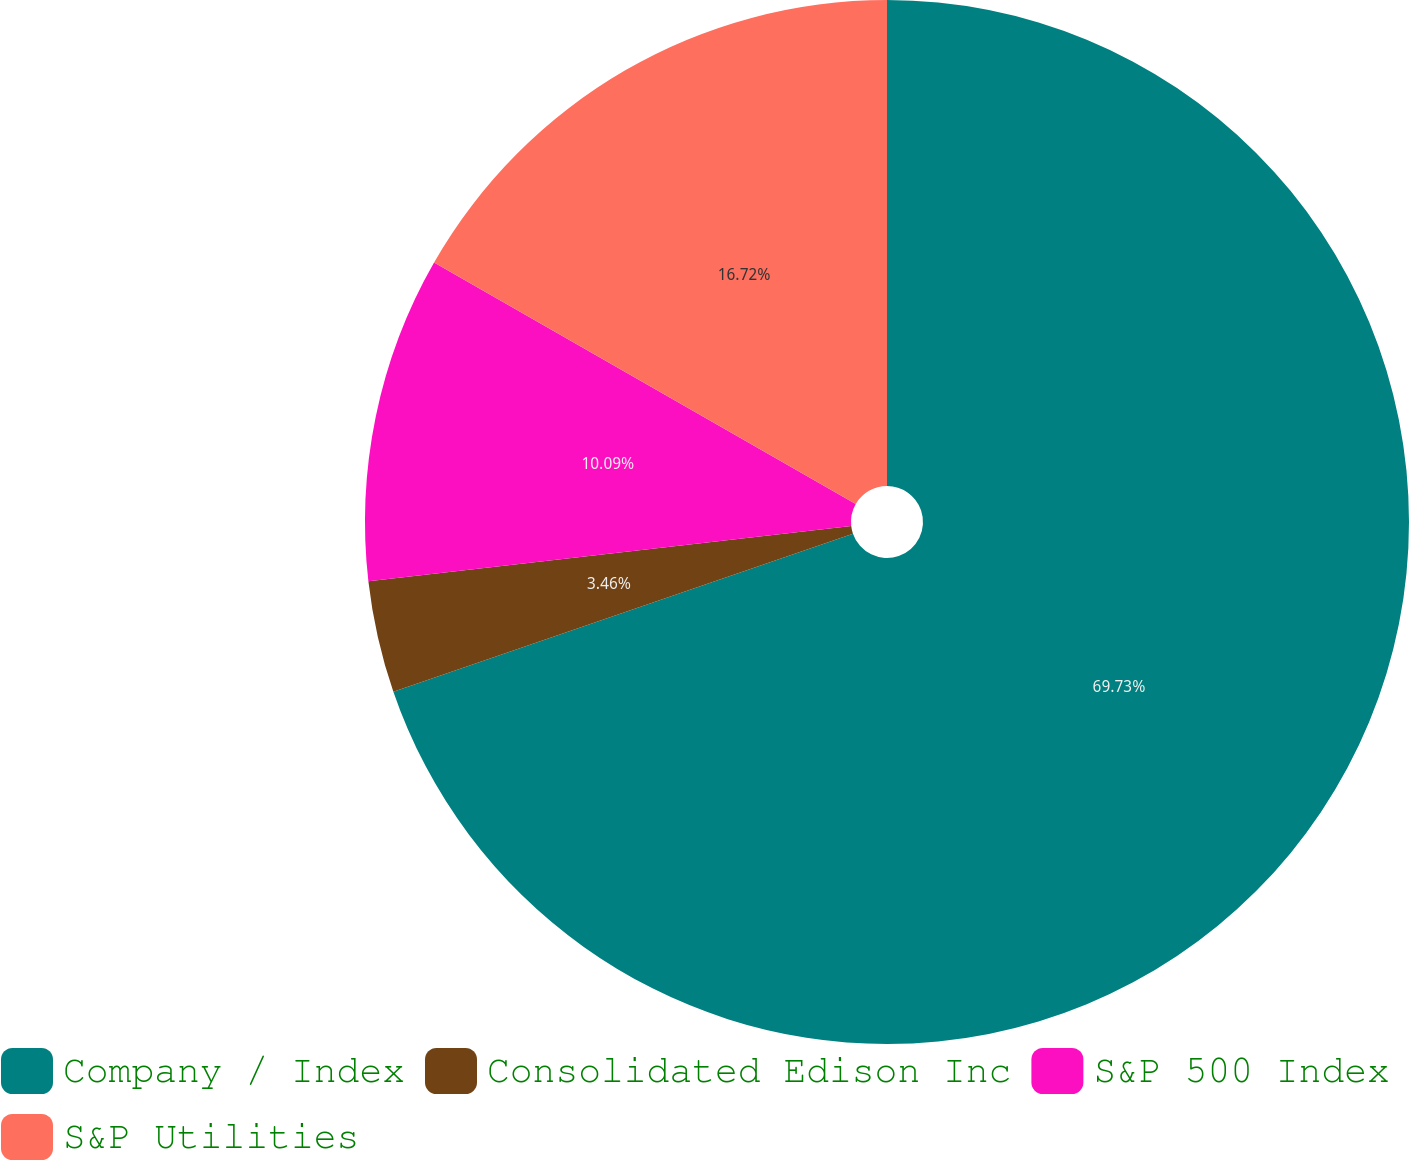Convert chart. <chart><loc_0><loc_0><loc_500><loc_500><pie_chart><fcel>Company / Index<fcel>Consolidated Edison Inc<fcel>S&P 500 Index<fcel>S&P Utilities<nl><fcel>69.73%<fcel>3.46%<fcel>10.09%<fcel>16.72%<nl></chart> 